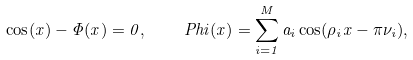Convert formula to latex. <formula><loc_0><loc_0><loc_500><loc_500>\cos ( x ) - \Phi ( x ) = 0 , \quad P h i ( x ) = \sum _ { i = 1 } ^ { M } a _ { i } \cos ( \rho _ { i } x - \pi \nu _ { i } ) ,</formula> 